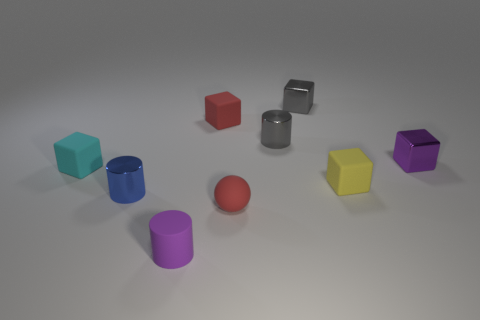Are there more metallic objects right of the small yellow block than gray objects left of the cyan cube?
Keep it short and to the point. Yes. What color is the small metallic cylinder that is to the left of the shiny cylinder on the right side of the small blue metal cylinder?
Provide a short and direct response. Blue. Are there any matte objects that have the same color as the tiny rubber ball?
Keep it short and to the point. Yes. The tiny purple rubber object has what shape?
Make the answer very short. Cylinder. What size is the matte thing that is the same color as the matte sphere?
Your response must be concise. Small. There is a rubber thing to the right of the small matte ball; how many cubes are right of it?
Your answer should be very brief. 1. How many other things are the same material as the cyan block?
Provide a short and direct response. 4. Is the small purple thing that is to the right of the purple cylinder made of the same material as the red thing in front of the tiny blue cylinder?
Make the answer very short. No. Is there any other thing that has the same shape as the tiny yellow matte object?
Give a very brief answer. Yes. Is the small cyan thing made of the same material as the tiny purple thing that is behind the small cyan object?
Your response must be concise. No. 